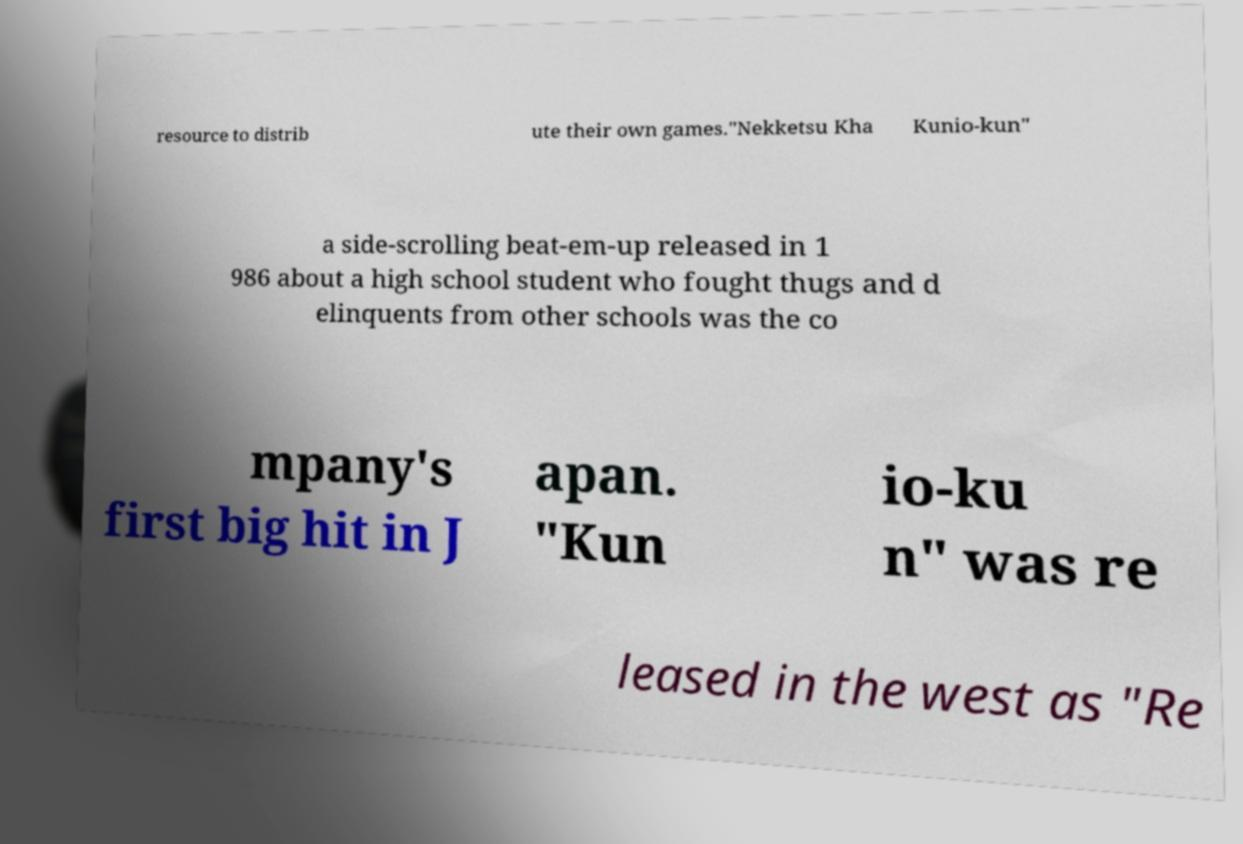What messages or text are displayed in this image? I need them in a readable, typed format. resource to distrib ute their own games."Nekketsu Kha Kunio-kun" a side-scrolling beat-em-up released in 1 986 about a high school student who fought thugs and d elinquents from other schools was the co mpany's first big hit in J apan. "Kun io-ku n" was re leased in the west as "Re 